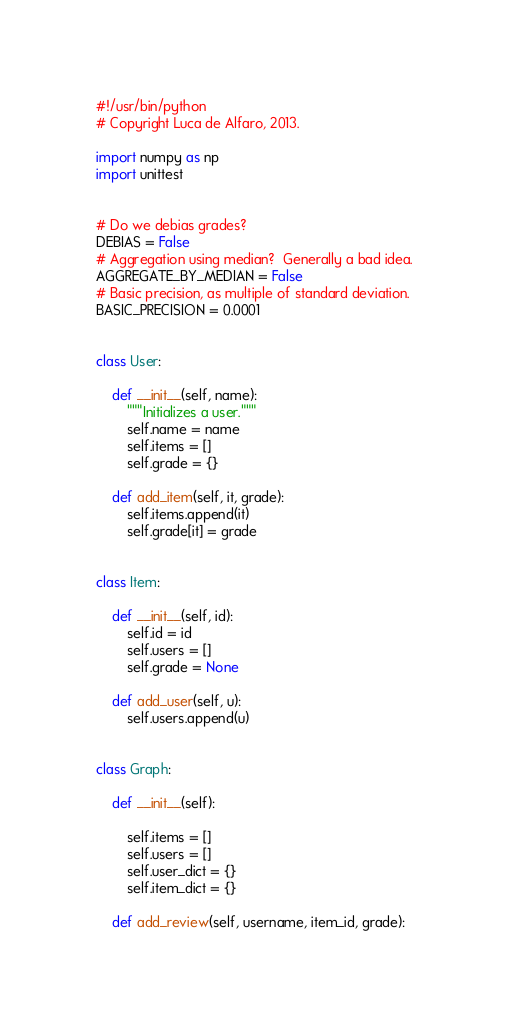<code> <loc_0><loc_0><loc_500><loc_500><_Python_>#!/usr/bin/python
# Copyright Luca de Alfaro, 2013. 

import numpy as np
import unittest


# Do we debias grades?
DEBIAS = False
# Aggregation using median?  Generally a bad idea.
AGGREGATE_BY_MEDIAN = False
# Basic precision, as multiple of standard deviation.
BASIC_PRECISION = 0.0001


class User:
    
    def __init__(self, name):
        """Initializes a user."""
        self.name = name
        self.items = []
        self.grade = {}
        
    def add_item(self, it, grade):
        self.items.append(it)
        self.grade[it] = grade
        

class Item:
    
    def __init__(self, id):
        self.id = id
        self.users = []
        self.grade = None
    
    def add_user(self, u):
        self.users.append(u)


class Graph:
    
    def __init__(self):
        
        self.items = []
        self.users = []
        self.user_dict = {}
        self.item_dict = {}
        
    def add_review(self, username, item_id, grade):</code> 